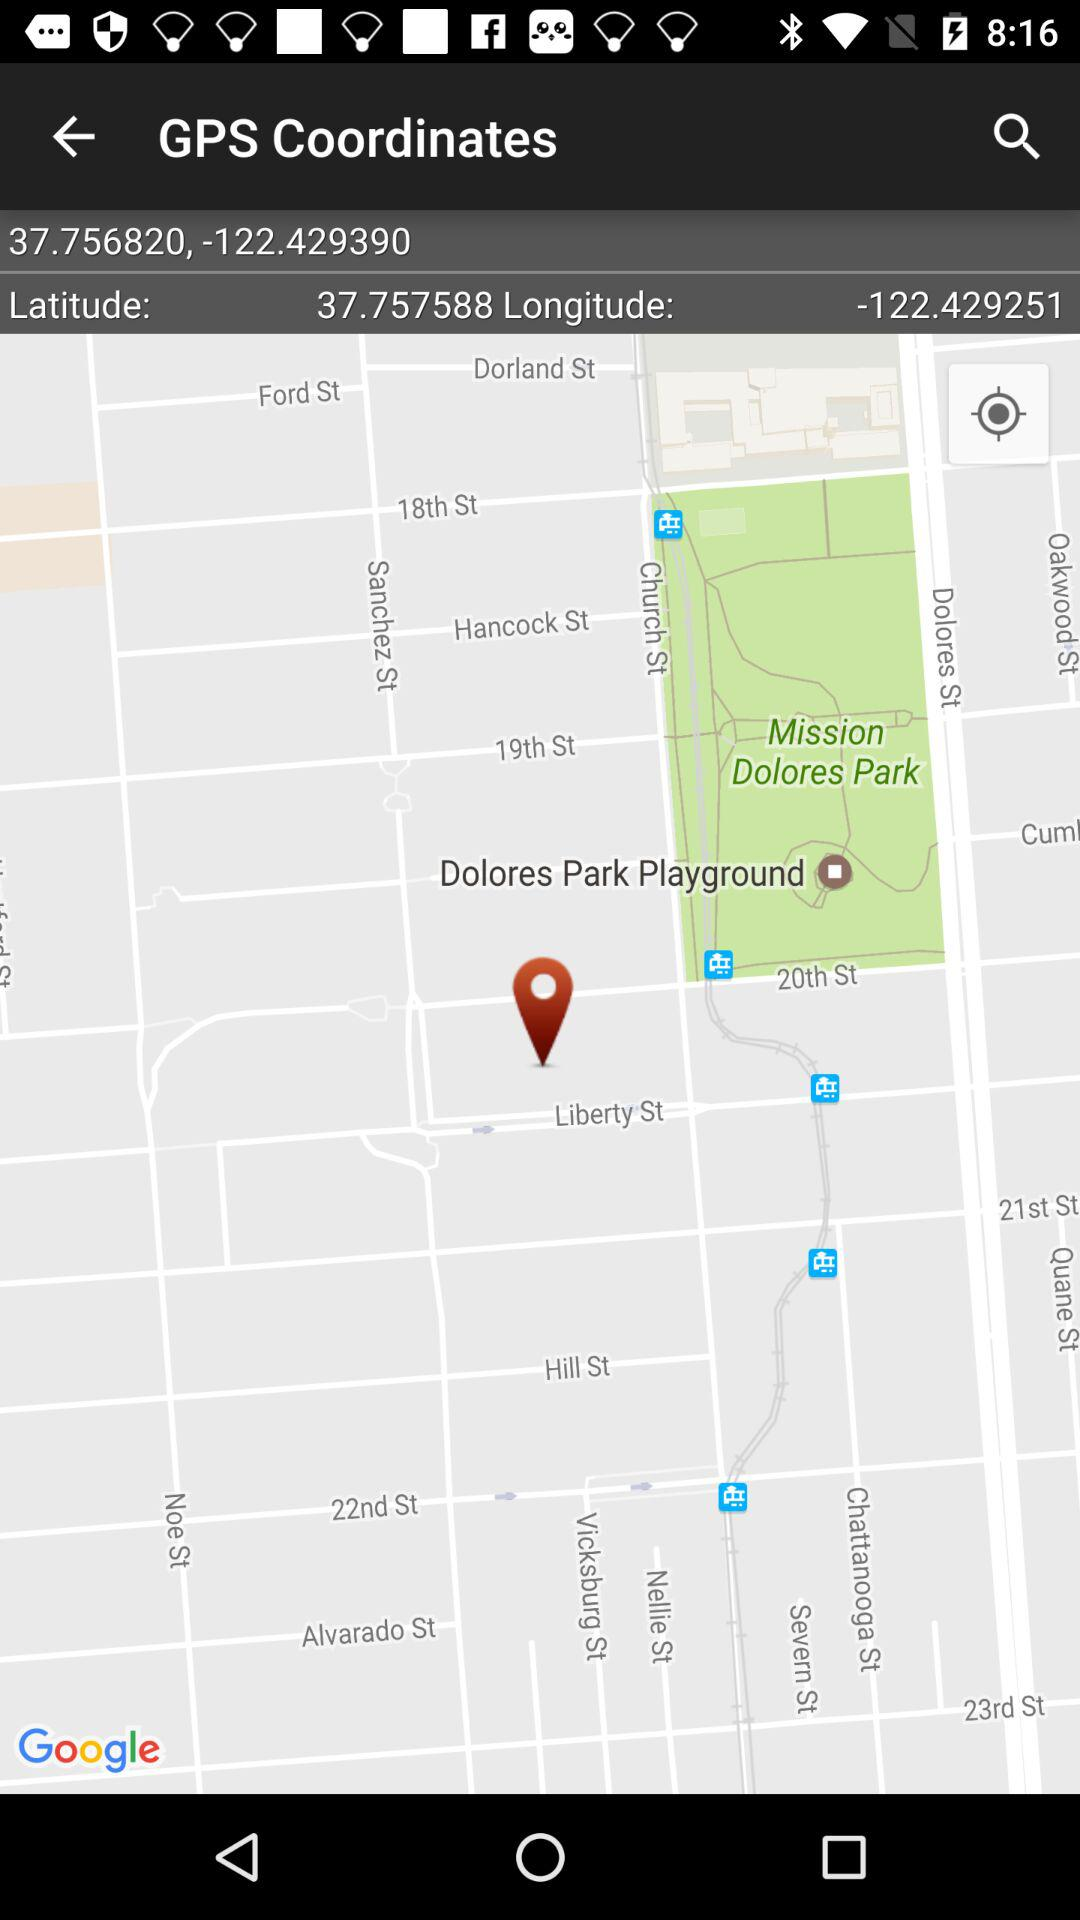In which city is Dolores Park?
When the provided information is insufficient, respond with <no answer>. <no answer> 